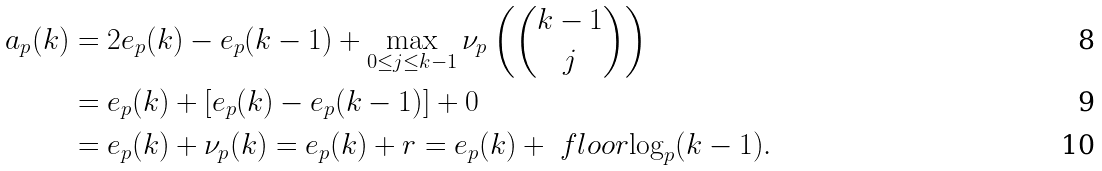<formula> <loc_0><loc_0><loc_500><loc_500>a _ { p } ( k ) & = 2 e _ { p } ( k ) - e _ { p } ( k - 1 ) + \max _ { 0 \leq j \leq k - 1 } \nu _ { p } \left ( \binom { k - 1 } { j } \right ) \\ & = e _ { p } ( k ) + \left [ e _ { p } ( k ) - e _ { p } ( k - 1 ) \right ] + 0 \\ & = e _ { p } ( k ) + \nu _ { p } ( k ) = e _ { p } ( k ) + r = e _ { p } ( k ) + \ f l o o r { \log _ { p } ( k - 1 ) } .</formula> 